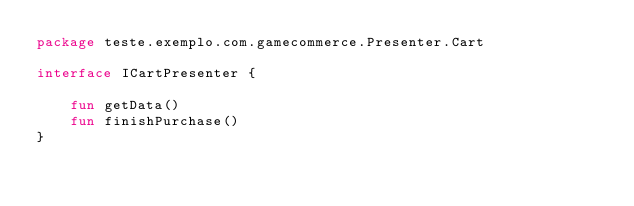<code> <loc_0><loc_0><loc_500><loc_500><_Kotlin_>package teste.exemplo.com.gamecommerce.Presenter.Cart

interface ICartPresenter {

    fun getData()
    fun finishPurchase()
}</code> 